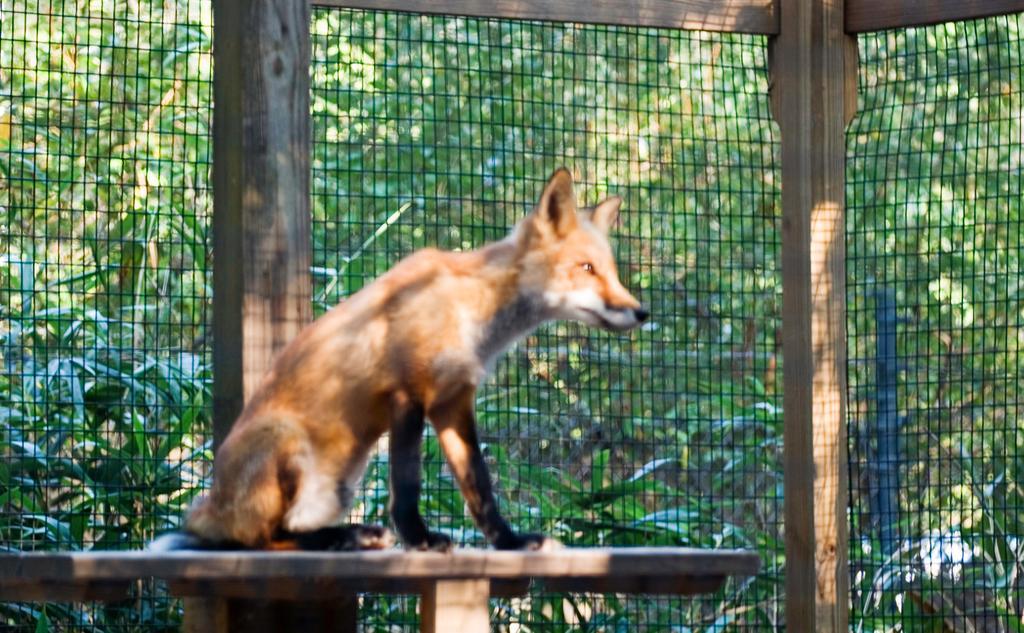Please provide a concise description of this image. In the middle of this image, there is a dog, sitting on a wooden table. Beside this dog, there is a fence attached to the wooden poles. Through this fence, there are trees. 